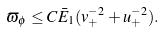<formula> <loc_0><loc_0><loc_500><loc_500>\varpi _ { \phi } \leq C \bar { E } _ { 1 } ( v _ { + } ^ { - 2 } + u _ { + } ^ { - 2 } ) .</formula> 